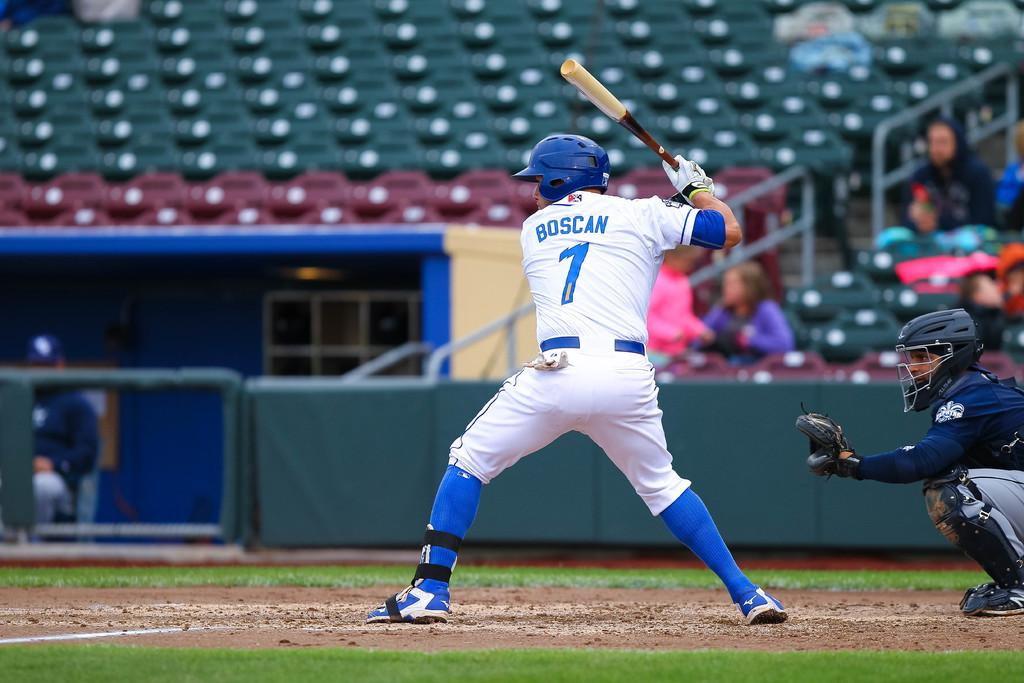<image>
Create a compact narrative representing the image presented. Player number 7 gets ready to hit the ball. 